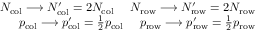Convert formula to latex. <formula><loc_0><loc_0><loc_500><loc_500>\begin{array} { r } { N _ { c o l } \longrightarrow N _ { c o l } ^ { \prime } = 2 N _ { c o l } \ \ \ \ N _ { r o w } \longrightarrow N _ { r o w } ^ { \prime } = 2 N _ { r o w } } \\ { p _ { c o l } \longrightarrow p _ { c o l } ^ { \prime } = \frac { 1 } { 2 } p _ { c o l } \ \ \ \ p _ { r o w } \longrightarrow p _ { r o w } ^ { \prime } = \frac { 1 } { 2 } p _ { r o w } } \end{array}</formula> 